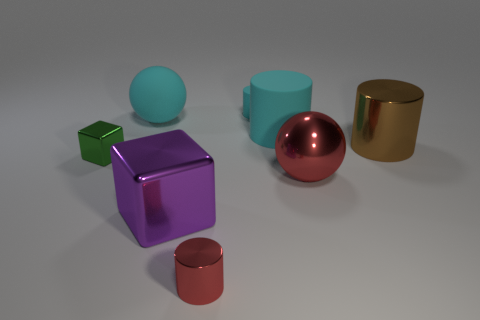There is a large object that is left of the small cyan thing and on the right side of the large cyan ball; what shape is it?
Give a very brief answer. Cube. Is there a brown matte cube that has the same size as the brown cylinder?
Provide a short and direct response. No. Does the large shiny cube have the same color as the small metallic thing that is on the left side of the tiny red metallic cylinder?
Make the answer very short. No. What material is the big red sphere?
Offer a terse response. Metal. There is a tiny object behind the large brown cylinder; what is its color?
Offer a terse response. Cyan. How many tiny metal cubes are the same color as the big metallic block?
Provide a succinct answer. 0. How many big things are left of the tiny red metallic thing and in front of the rubber sphere?
Your answer should be compact. 1. There is a green thing that is the same size as the red cylinder; what is its shape?
Your response must be concise. Cube. What is the size of the cyan rubber sphere?
Give a very brief answer. Large. The big cyan thing on the right side of the small object that is in front of the red shiny thing right of the small shiny cylinder is made of what material?
Give a very brief answer. Rubber. 